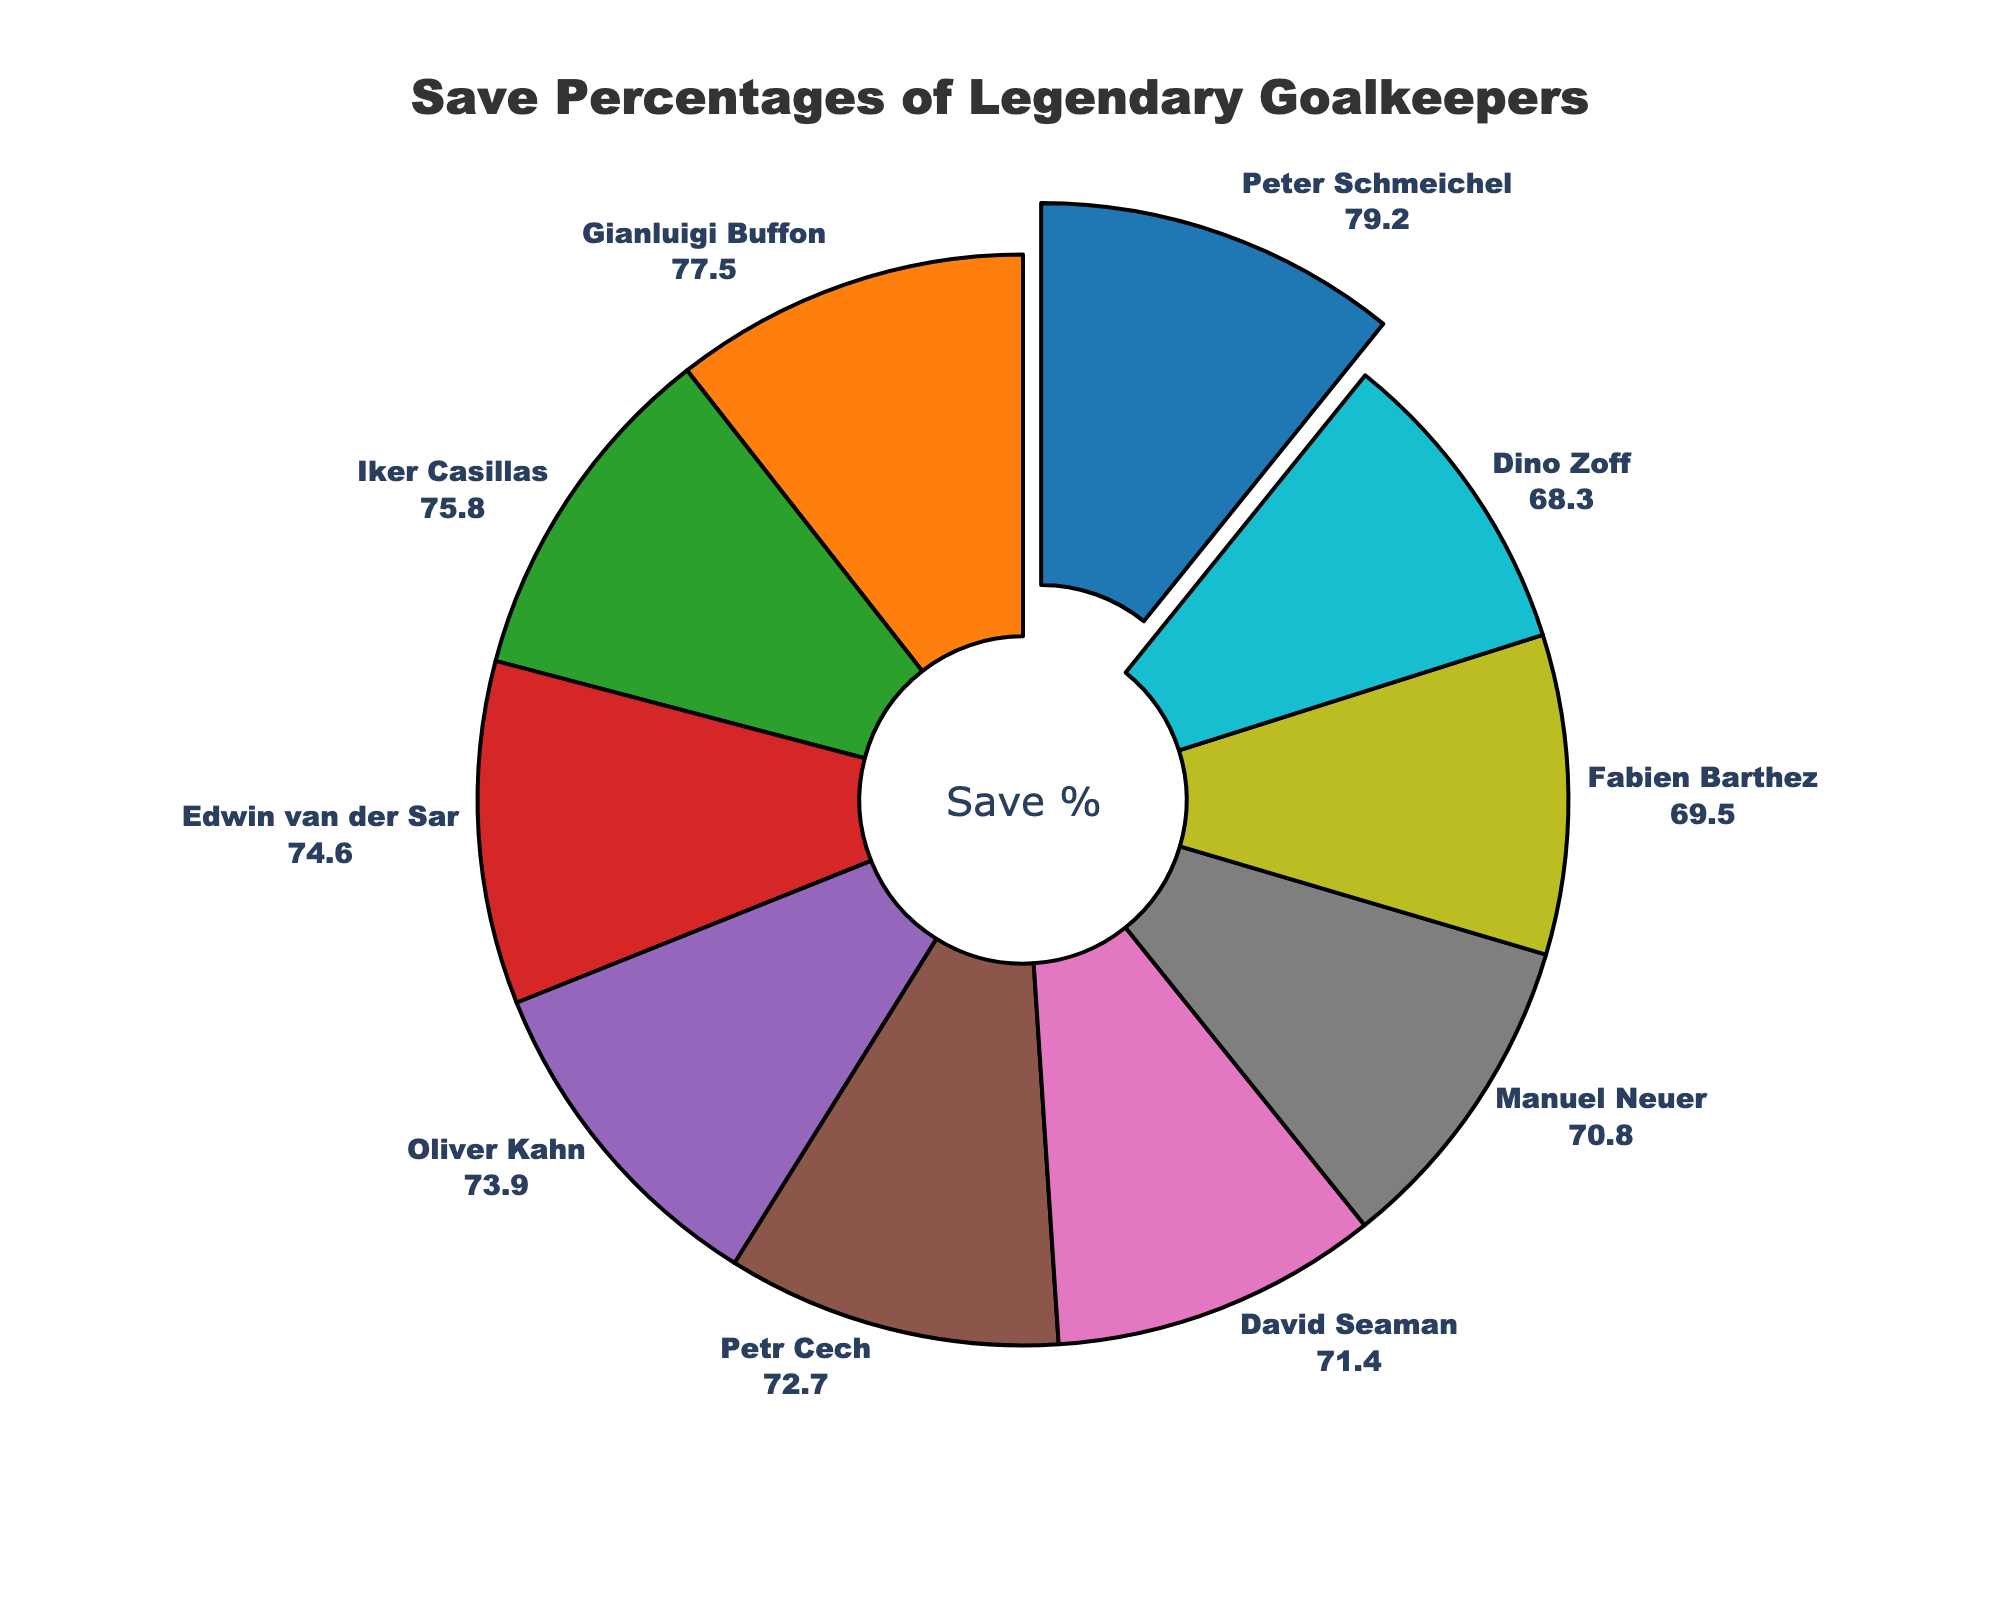Which goalkeeper has the highest save percentage? The goalkeeper with the highest save percentage can be identified by looking for the slice that is slightly separated from the pie chart. The goalkeeper listed in the label with the highest percentage value is Peter Schmeichel.
Answer: Peter Schmeichel What is the approximate difference in save percentage between Peter Schmeichel and Dino Zoff? By comparing the save percentages, Peter Schmeichel has 79.2% and Dino Zoff has 68.3%. The difference can be calculated as 79.2 - 68.3.
Answer: 10.9% If you were to rank the goalkeepers by their save percentages, who would be third on the list? Sorting the save percentages in descending order, the third-highest value belongs to Iker Casillas with 75.8%.
Answer: Iker Casillas Which goalkeepers have a save percentage lower than 70%? By examining the percentages around the pie chart, both Fabien Barthez and Dino Zoff have save percentages below 70%.
Answer: Fabien Barthez and Dino Zoff What is the average save percentage of Gianluigi Buffon, Iker Casillas, and Edwin van der Sar? Averaging the save percentages of Gianluigi Buffon (77.5%), Iker Casillas (75.8%), and Edwin van der Sar (74.6%), the calculation is (77.5 + 75.8 + 74.6) / 3.
Answer: 75.96% How much higher is Peter Schmeichel's save percentage compared to the average save percentage of the goalkeepers? First, calculate the average save percentage of the goalkeepers, then subtract the average from Peter Schmeichel's percentage. The mean of the given values is (79.2 + 77.5 + 75.8 + 74.6 + 73.9 + 72.7 + 71.4 + 70.8 + 69.5 + 68.3) / 10 = 73.37%. The difference is 79.2 - 73.37.
Answer: 5.83% Which slice of the pie chart represents the smallest save percentage and what color is it? The smallest slice will have the label indicating the lowest save percentage, which is Dino Zoff with 68.3%. The color assigned might vary but usually it follows the color sequence provided.
Answer: Dino Zoff, light blue How many goalkeepers have save percentages greater than 75%? By counting the goalkeepers with save percentages above 75%, there are Peter Schmeichel, Gianluigi Buffon, and Iker Casillas.
Answer: 3 Who has a higher save percentage, David Seaman or Manuel Neuer? Comparing the save percentages directly from the pie chart, David Seaman has 71.4% while Manuel Neuer has 70.8%.
Answer: David Seaman 